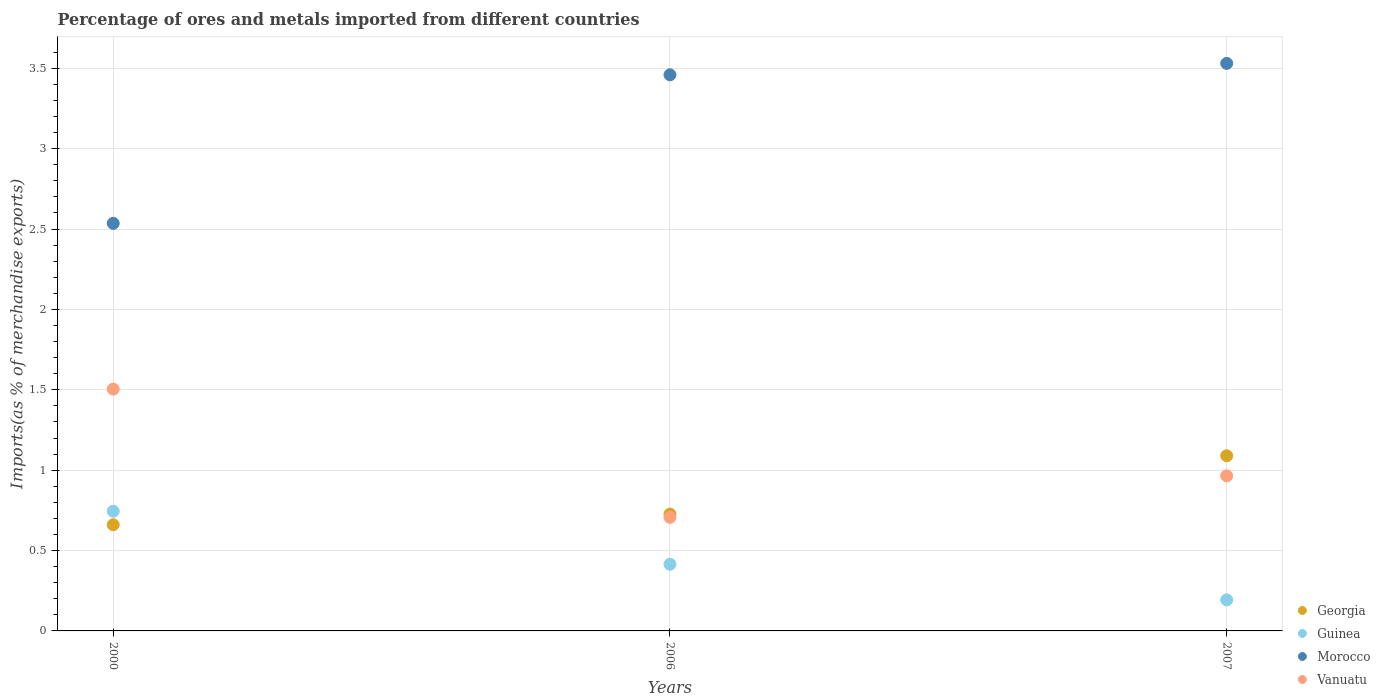How many different coloured dotlines are there?
Your answer should be very brief. 4. Is the number of dotlines equal to the number of legend labels?
Your answer should be very brief. Yes. What is the percentage of imports to different countries in Georgia in 2007?
Offer a very short reply. 1.09. Across all years, what is the maximum percentage of imports to different countries in Guinea?
Keep it short and to the point. 0.74. Across all years, what is the minimum percentage of imports to different countries in Georgia?
Offer a very short reply. 0.66. In which year was the percentage of imports to different countries in Guinea minimum?
Your response must be concise. 2007. What is the total percentage of imports to different countries in Georgia in the graph?
Your answer should be very brief. 2.48. What is the difference between the percentage of imports to different countries in Morocco in 2000 and that in 2007?
Your answer should be very brief. -1. What is the difference between the percentage of imports to different countries in Morocco in 2006 and the percentage of imports to different countries in Georgia in 2007?
Make the answer very short. 2.37. What is the average percentage of imports to different countries in Morocco per year?
Provide a succinct answer. 3.17. In the year 2006, what is the difference between the percentage of imports to different countries in Vanuatu and percentage of imports to different countries in Georgia?
Your answer should be very brief. -0.02. In how many years, is the percentage of imports to different countries in Vanuatu greater than 1.9 %?
Provide a short and direct response. 0. What is the ratio of the percentage of imports to different countries in Georgia in 2000 to that in 2006?
Give a very brief answer. 0.91. What is the difference between the highest and the second highest percentage of imports to different countries in Morocco?
Your response must be concise. 0.07. What is the difference between the highest and the lowest percentage of imports to different countries in Vanuatu?
Offer a very short reply. 0.8. Is the sum of the percentage of imports to different countries in Morocco in 2000 and 2007 greater than the maximum percentage of imports to different countries in Guinea across all years?
Give a very brief answer. Yes. Is it the case that in every year, the sum of the percentage of imports to different countries in Vanuatu and percentage of imports to different countries in Georgia  is greater than the sum of percentage of imports to different countries in Morocco and percentage of imports to different countries in Guinea?
Make the answer very short. Yes. Is it the case that in every year, the sum of the percentage of imports to different countries in Vanuatu and percentage of imports to different countries in Guinea  is greater than the percentage of imports to different countries in Georgia?
Your response must be concise. Yes. Does the percentage of imports to different countries in Georgia monotonically increase over the years?
Provide a succinct answer. Yes. Is the percentage of imports to different countries in Guinea strictly greater than the percentage of imports to different countries in Vanuatu over the years?
Give a very brief answer. No. How many years are there in the graph?
Provide a succinct answer. 3. Are the values on the major ticks of Y-axis written in scientific E-notation?
Your response must be concise. No. Does the graph contain grids?
Provide a succinct answer. Yes. Where does the legend appear in the graph?
Your response must be concise. Bottom right. How many legend labels are there?
Offer a very short reply. 4. What is the title of the graph?
Provide a succinct answer. Percentage of ores and metals imported from different countries. What is the label or title of the X-axis?
Your answer should be very brief. Years. What is the label or title of the Y-axis?
Your answer should be very brief. Imports(as % of merchandise exports). What is the Imports(as % of merchandise exports) of Georgia in 2000?
Your response must be concise. 0.66. What is the Imports(as % of merchandise exports) of Guinea in 2000?
Provide a short and direct response. 0.74. What is the Imports(as % of merchandise exports) of Morocco in 2000?
Your answer should be compact. 2.54. What is the Imports(as % of merchandise exports) of Vanuatu in 2000?
Provide a succinct answer. 1.5. What is the Imports(as % of merchandise exports) of Georgia in 2006?
Give a very brief answer. 0.73. What is the Imports(as % of merchandise exports) of Guinea in 2006?
Your response must be concise. 0.41. What is the Imports(as % of merchandise exports) in Morocco in 2006?
Offer a very short reply. 3.46. What is the Imports(as % of merchandise exports) in Vanuatu in 2006?
Make the answer very short. 0.71. What is the Imports(as % of merchandise exports) in Georgia in 2007?
Offer a very short reply. 1.09. What is the Imports(as % of merchandise exports) in Guinea in 2007?
Offer a terse response. 0.19. What is the Imports(as % of merchandise exports) in Morocco in 2007?
Your answer should be very brief. 3.53. What is the Imports(as % of merchandise exports) of Vanuatu in 2007?
Ensure brevity in your answer.  0.96. Across all years, what is the maximum Imports(as % of merchandise exports) in Georgia?
Keep it short and to the point. 1.09. Across all years, what is the maximum Imports(as % of merchandise exports) of Guinea?
Keep it short and to the point. 0.74. Across all years, what is the maximum Imports(as % of merchandise exports) of Morocco?
Provide a succinct answer. 3.53. Across all years, what is the maximum Imports(as % of merchandise exports) of Vanuatu?
Your response must be concise. 1.5. Across all years, what is the minimum Imports(as % of merchandise exports) of Georgia?
Your answer should be compact. 0.66. Across all years, what is the minimum Imports(as % of merchandise exports) of Guinea?
Provide a succinct answer. 0.19. Across all years, what is the minimum Imports(as % of merchandise exports) in Morocco?
Provide a succinct answer. 2.54. Across all years, what is the minimum Imports(as % of merchandise exports) of Vanuatu?
Your answer should be very brief. 0.71. What is the total Imports(as % of merchandise exports) of Georgia in the graph?
Make the answer very short. 2.48. What is the total Imports(as % of merchandise exports) in Guinea in the graph?
Provide a succinct answer. 1.35. What is the total Imports(as % of merchandise exports) of Morocco in the graph?
Ensure brevity in your answer.  9.53. What is the total Imports(as % of merchandise exports) in Vanuatu in the graph?
Ensure brevity in your answer.  3.18. What is the difference between the Imports(as % of merchandise exports) of Georgia in 2000 and that in 2006?
Keep it short and to the point. -0.07. What is the difference between the Imports(as % of merchandise exports) in Guinea in 2000 and that in 2006?
Your answer should be compact. 0.33. What is the difference between the Imports(as % of merchandise exports) of Morocco in 2000 and that in 2006?
Offer a very short reply. -0.92. What is the difference between the Imports(as % of merchandise exports) in Vanuatu in 2000 and that in 2006?
Keep it short and to the point. 0.8. What is the difference between the Imports(as % of merchandise exports) of Georgia in 2000 and that in 2007?
Keep it short and to the point. -0.43. What is the difference between the Imports(as % of merchandise exports) of Guinea in 2000 and that in 2007?
Ensure brevity in your answer.  0.55. What is the difference between the Imports(as % of merchandise exports) in Morocco in 2000 and that in 2007?
Your answer should be compact. -0.99. What is the difference between the Imports(as % of merchandise exports) of Vanuatu in 2000 and that in 2007?
Ensure brevity in your answer.  0.54. What is the difference between the Imports(as % of merchandise exports) in Georgia in 2006 and that in 2007?
Ensure brevity in your answer.  -0.36. What is the difference between the Imports(as % of merchandise exports) of Guinea in 2006 and that in 2007?
Your response must be concise. 0.22. What is the difference between the Imports(as % of merchandise exports) in Morocco in 2006 and that in 2007?
Give a very brief answer. -0.07. What is the difference between the Imports(as % of merchandise exports) in Vanuatu in 2006 and that in 2007?
Give a very brief answer. -0.26. What is the difference between the Imports(as % of merchandise exports) in Georgia in 2000 and the Imports(as % of merchandise exports) in Guinea in 2006?
Your answer should be compact. 0.25. What is the difference between the Imports(as % of merchandise exports) of Georgia in 2000 and the Imports(as % of merchandise exports) of Morocco in 2006?
Provide a succinct answer. -2.8. What is the difference between the Imports(as % of merchandise exports) in Georgia in 2000 and the Imports(as % of merchandise exports) in Vanuatu in 2006?
Provide a succinct answer. -0.05. What is the difference between the Imports(as % of merchandise exports) of Guinea in 2000 and the Imports(as % of merchandise exports) of Morocco in 2006?
Your answer should be compact. -2.71. What is the difference between the Imports(as % of merchandise exports) of Guinea in 2000 and the Imports(as % of merchandise exports) of Vanuatu in 2006?
Give a very brief answer. 0.04. What is the difference between the Imports(as % of merchandise exports) of Morocco in 2000 and the Imports(as % of merchandise exports) of Vanuatu in 2006?
Offer a very short reply. 1.83. What is the difference between the Imports(as % of merchandise exports) in Georgia in 2000 and the Imports(as % of merchandise exports) in Guinea in 2007?
Your response must be concise. 0.47. What is the difference between the Imports(as % of merchandise exports) in Georgia in 2000 and the Imports(as % of merchandise exports) in Morocco in 2007?
Offer a terse response. -2.87. What is the difference between the Imports(as % of merchandise exports) of Georgia in 2000 and the Imports(as % of merchandise exports) of Vanuatu in 2007?
Give a very brief answer. -0.3. What is the difference between the Imports(as % of merchandise exports) in Guinea in 2000 and the Imports(as % of merchandise exports) in Morocco in 2007?
Your answer should be compact. -2.79. What is the difference between the Imports(as % of merchandise exports) of Guinea in 2000 and the Imports(as % of merchandise exports) of Vanuatu in 2007?
Give a very brief answer. -0.22. What is the difference between the Imports(as % of merchandise exports) in Morocco in 2000 and the Imports(as % of merchandise exports) in Vanuatu in 2007?
Give a very brief answer. 1.57. What is the difference between the Imports(as % of merchandise exports) of Georgia in 2006 and the Imports(as % of merchandise exports) of Guinea in 2007?
Provide a succinct answer. 0.53. What is the difference between the Imports(as % of merchandise exports) of Georgia in 2006 and the Imports(as % of merchandise exports) of Morocco in 2007?
Your answer should be compact. -2.8. What is the difference between the Imports(as % of merchandise exports) of Georgia in 2006 and the Imports(as % of merchandise exports) of Vanuatu in 2007?
Keep it short and to the point. -0.24. What is the difference between the Imports(as % of merchandise exports) in Guinea in 2006 and the Imports(as % of merchandise exports) in Morocco in 2007?
Make the answer very short. -3.12. What is the difference between the Imports(as % of merchandise exports) in Guinea in 2006 and the Imports(as % of merchandise exports) in Vanuatu in 2007?
Provide a short and direct response. -0.55. What is the difference between the Imports(as % of merchandise exports) in Morocco in 2006 and the Imports(as % of merchandise exports) in Vanuatu in 2007?
Provide a succinct answer. 2.49. What is the average Imports(as % of merchandise exports) of Georgia per year?
Provide a succinct answer. 0.83. What is the average Imports(as % of merchandise exports) in Guinea per year?
Provide a short and direct response. 0.45. What is the average Imports(as % of merchandise exports) in Morocco per year?
Your response must be concise. 3.17. What is the average Imports(as % of merchandise exports) in Vanuatu per year?
Your response must be concise. 1.06. In the year 2000, what is the difference between the Imports(as % of merchandise exports) in Georgia and Imports(as % of merchandise exports) in Guinea?
Your answer should be very brief. -0.08. In the year 2000, what is the difference between the Imports(as % of merchandise exports) in Georgia and Imports(as % of merchandise exports) in Morocco?
Provide a succinct answer. -1.87. In the year 2000, what is the difference between the Imports(as % of merchandise exports) of Georgia and Imports(as % of merchandise exports) of Vanuatu?
Your response must be concise. -0.84. In the year 2000, what is the difference between the Imports(as % of merchandise exports) in Guinea and Imports(as % of merchandise exports) in Morocco?
Provide a short and direct response. -1.79. In the year 2000, what is the difference between the Imports(as % of merchandise exports) in Guinea and Imports(as % of merchandise exports) in Vanuatu?
Give a very brief answer. -0.76. In the year 2000, what is the difference between the Imports(as % of merchandise exports) of Morocco and Imports(as % of merchandise exports) of Vanuatu?
Ensure brevity in your answer.  1.03. In the year 2006, what is the difference between the Imports(as % of merchandise exports) in Georgia and Imports(as % of merchandise exports) in Guinea?
Your response must be concise. 0.31. In the year 2006, what is the difference between the Imports(as % of merchandise exports) of Georgia and Imports(as % of merchandise exports) of Morocco?
Offer a terse response. -2.73. In the year 2006, what is the difference between the Imports(as % of merchandise exports) of Georgia and Imports(as % of merchandise exports) of Vanuatu?
Offer a terse response. 0.02. In the year 2006, what is the difference between the Imports(as % of merchandise exports) of Guinea and Imports(as % of merchandise exports) of Morocco?
Your answer should be very brief. -3.04. In the year 2006, what is the difference between the Imports(as % of merchandise exports) in Guinea and Imports(as % of merchandise exports) in Vanuatu?
Provide a short and direct response. -0.29. In the year 2006, what is the difference between the Imports(as % of merchandise exports) of Morocco and Imports(as % of merchandise exports) of Vanuatu?
Your answer should be very brief. 2.75. In the year 2007, what is the difference between the Imports(as % of merchandise exports) in Georgia and Imports(as % of merchandise exports) in Guinea?
Offer a terse response. 0.9. In the year 2007, what is the difference between the Imports(as % of merchandise exports) of Georgia and Imports(as % of merchandise exports) of Morocco?
Provide a short and direct response. -2.44. In the year 2007, what is the difference between the Imports(as % of merchandise exports) in Georgia and Imports(as % of merchandise exports) in Vanuatu?
Offer a terse response. 0.12. In the year 2007, what is the difference between the Imports(as % of merchandise exports) in Guinea and Imports(as % of merchandise exports) in Morocco?
Your answer should be very brief. -3.34. In the year 2007, what is the difference between the Imports(as % of merchandise exports) in Guinea and Imports(as % of merchandise exports) in Vanuatu?
Your answer should be compact. -0.77. In the year 2007, what is the difference between the Imports(as % of merchandise exports) in Morocco and Imports(as % of merchandise exports) in Vanuatu?
Provide a succinct answer. 2.57. What is the ratio of the Imports(as % of merchandise exports) in Georgia in 2000 to that in 2006?
Your answer should be very brief. 0.91. What is the ratio of the Imports(as % of merchandise exports) in Guinea in 2000 to that in 2006?
Keep it short and to the point. 1.8. What is the ratio of the Imports(as % of merchandise exports) in Morocco in 2000 to that in 2006?
Provide a short and direct response. 0.73. What is the ratio of the Imports(as % of merchandise exports) of Vanuatu in 2000 to that in 2006?
Your response must be concise. 2.13. What is the ratio of the Imports(as % of merchandise exports) of Georgia in 2000 to that in 2007?
Your answer should be very brief. 0.61. What is the ratio of the Imports(as % of merchandise exports) in Guinea in 2000 to that in 2007?
Your answer should be compact. 3.86. What is the ratio of the Imports(as % of merchandise exports) in Morocco in 2000 to that in 2007?
Your response must be concise. 0.72. What is the ratio of the Imports(as % of merchandise exports) in Vanuatu in 2000 to that in 2007?
Provide a short and direct response. 1.56. What is the ratio of the Imports(as % of merchandise exports) in Georgia in 2006 to that in 2007?
Your response must be concise. 0.67. What is the ratio of the Imports(as % of merchandise exports) of Guinea in 2006 to that in 2007?
Offer a terse response. 2.15. What is the ratio of the Imports(as % of merchandise exports) in Morocco in 2006 to that in 2007?
Your answer should be compact. 0.98. What is the ratio of the Imports(as % of merchandise exports) in Vanuatu in 2006 to that in 2007?
Your answer should be very brief. 0.73. What is the difference between the highest and the second highest Imports(as % of merchandise exports) of Georgia?
Give a very brief answer. 0.36. What is the difference between the highest and the second highest Imports(as % of merchandise exports) of Guinea?
Your answer should be very brief. 0.33. What is the difference between the highest and the second highest Imports(as % of merchandise exports) of Morocco?
Offer a terse response. 0.07. What is the difference between the highest and the second highest Imports(as % of merchandise exports) of Vanuatu?
Give a very brief answer. 0.54. What is the difference between the highest and the lowest Imports(as % of merchandise exports) in Georgia?
Your answer should be very brief. 0.43. What is the difference between the highest and the lowest Imports(as % of merchandise exports) in Guinea?
Offer a terse response. 0.55. What is the difference between the highest and the lowest Imports(as % of merchandise exports) of Morocco?
Make the answer very short. 0.99. What is the difference between the highest and the lowest Imports(as % of merchandise exports) of Vanuatu?
Provide a short and direct response. 0.8. 